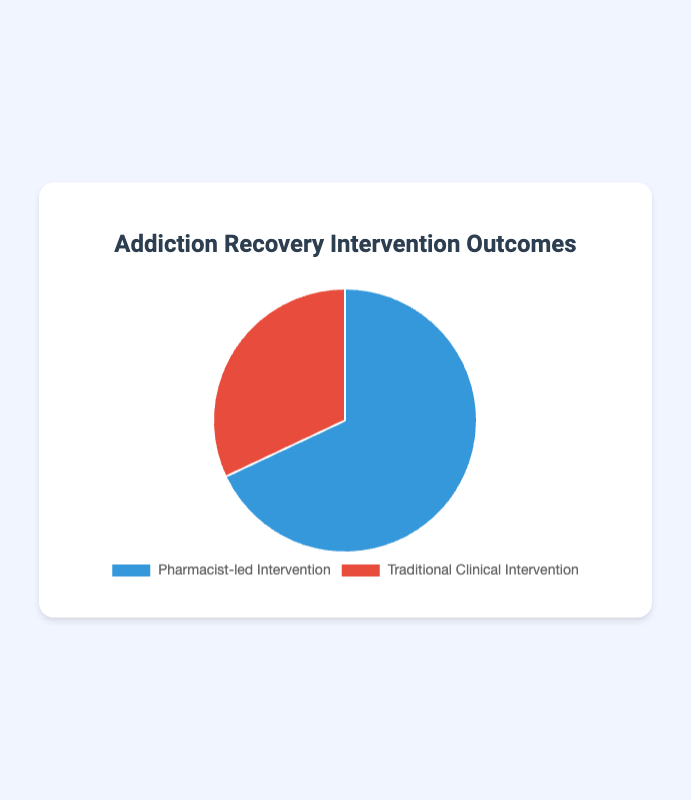Which intervention type has a higher addiction recovery rate? The pie chart shows two intervention types with their respective recovery rates. The Pharmacist-led Intervention has a recovery rate of 68%, which is higher than the Traditional Clinical Intervention at 32%.
Answer: Pharmacist-led Intervention What is the difference in addiction recovery rates between the two intervention types? The addiction recovery rate for Pharmacist-led Intervention is 68% and for Traditional Clinical Intervention is 32%. The difference between them is 68% - 32% = 36%.
Answer: 36% What percentage of the total does the Traditional Clinical Intervention account for? The pie chart represents the total recovery rates as 100%. The Traditional Clinical Intervention is shown as 32%. Thus, it accounts for 32% of the total.
Answer: 32% If the total number of recovered patients is 1000, how many patients benefited from each intervention? If 68% of patients benefited from Pharmacist-led Intervention and 32% from Traditional Clinical Intervention, calculations will be: Pharmacist-led: 68% of 1000 = 680, Traditional Clinical: 32% of 1000 = 320.
Answer: Pharmacist-led: 680, Traditional Clinical: 320 What colors are used to represent the intervention types in the pie chart? The pie chart uses blue for Pharmacist-led Intervention and red for Traditional Clinical Intervention.
Answer: Blue and Red Which intervention type accounts for less than half of the total addiction recovery rate? Less than half means less than 50%. The Traditional Clinical Intervention has a recovery rate of 32%, which is less than 50%.
Answer: Traditional Clinical Intervention What is the sum of the addiction recovery rates from both interventions? The recovery rates are 68% for Pharmacist-led Intervention and 32% for Traditional Clinical Intervention. The sum is 68% + 32% = 100%.
Answer: 100% What proportion of the addiction recovery rate is attributed to the Pharmacist-led Intervention compared to the total? The total recovery rate is 100%, and the Pharmacist-led Intervention accounts for 68% of it. Proportionally, it is 68/100 = 0.68 or 68%.
Answer: 68% What is the fraction of the recovery rate for Traditional Clinical Intervention out of the total recovery rate? The recovery rate for Traditional Clinical Intervention is 32% out of the total 100%. This can be represented as a fraction: 32/100 or simplified to 8/25.
Answer: 8/25 